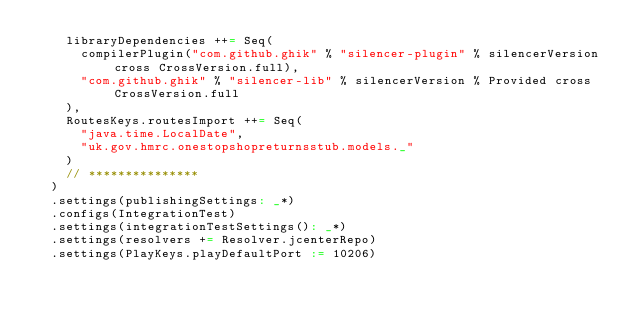Convert code to text. <code><loc_0><loc_0><loc_500><loc_500><_Scala_>    libraryDependencies ++= Seq(
      compilerPlugin("com.github.ghik" % "silencer-plugin" % silencerVersion cross CrossVersion.full),
      "com.github.ghik" % "silencer-lib" % silencerVersion % Provided cross CrossVersion.full
    ),
    RoutesKeys.routesImport ++= Seq(
      "java.time.LocalDate",
      "uk.gov.hmrc.onestopshopreturnsstub.models._"
    )
    // ***************
  )
  .settings(publishingSettings: _*)
  .configs(IntegrationTest)
  .settings(integrationTestSettings(): _*)
  .settings(resolvers += Resolver.jcenterRepo)
  .settings(PlayKeys.playDefaultPort := 10206)
</code> 